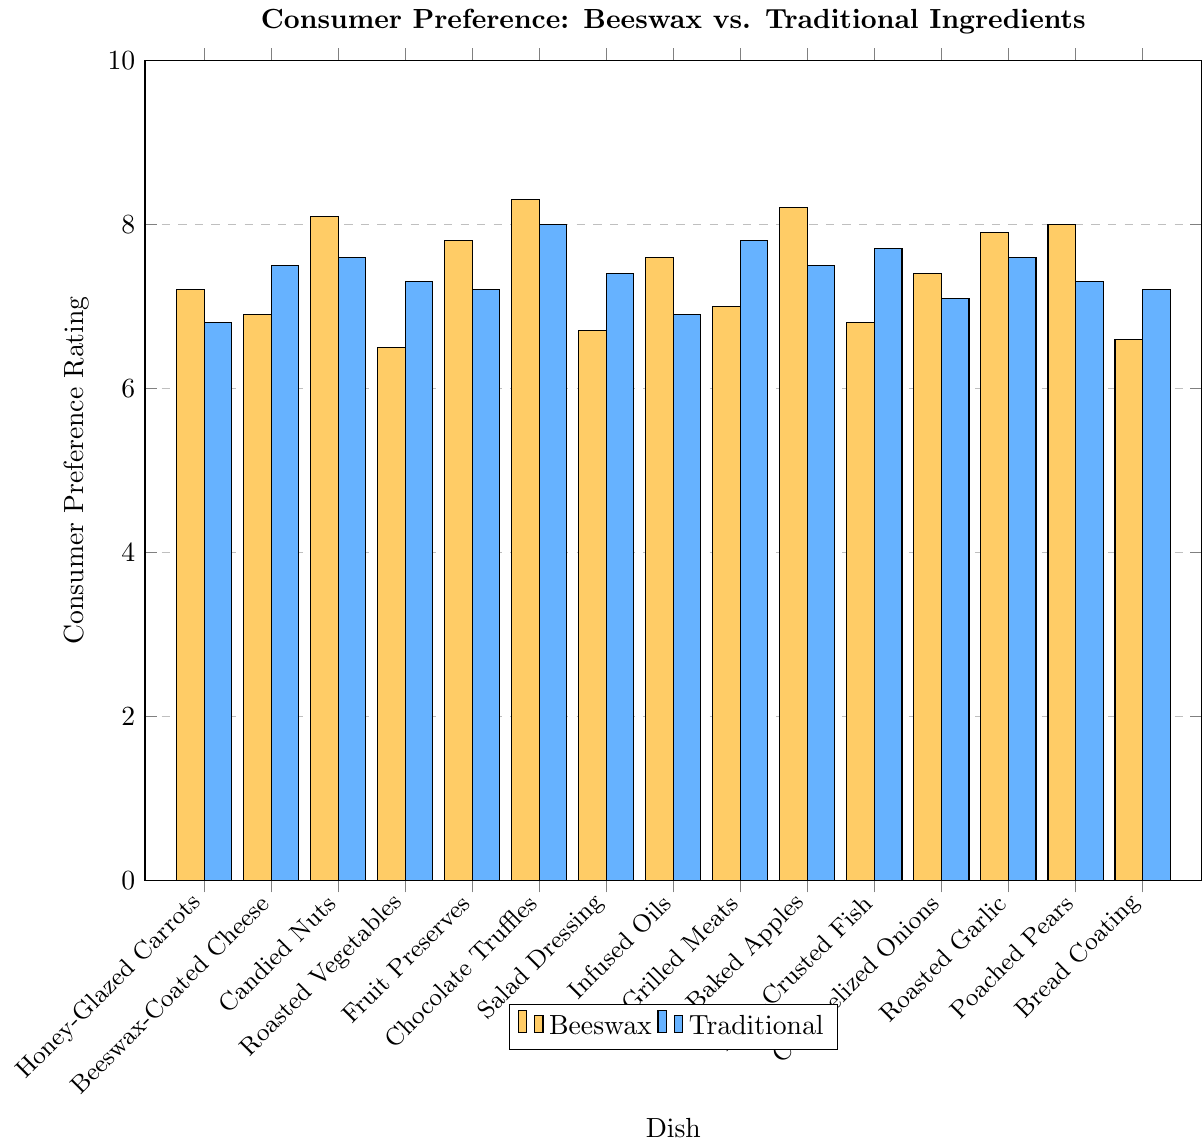What dish has the highest beeswax rating? To find the highest beeswax rating, look for the tallest bar in the beeswax series. The tallest bar belongs to "Chocolate Truffles" with a rating of 8.3.
Answer: Chocolate Truffles Which dish has the largest difference in preference rating between beeswax and traditional ingredients? Calculate the absolute difference between beeswax and traditional ratings for each dish. The largest difference is for "Herb-Crusted Fish" where the beeswax rating (6.8) is lower than the traditional rating (7.7) by 0.9.
Answer: Herb-Crusted Fish What is the average traditional rating across all dishes? Sum all traditional ratings and divide by the number of dishes. The sum of traditional ratings is (6.8 + 7.5 + 7.6 + 7.3 + 7.2 + 8.0 + 7.4 + 6.9 + 7.8 + 7.5 + 7.7 + 7.1 + 7.6 + 7.3 + 7.2) = 112.9, and there are 15 dishes, so the average is 112.9/15 = 7.53.
Answer: 7.53 Which dishes have beeswax ratings higher than their traditional counterparts? Compare each dish's beeswax rating to its traditional rating. The dishes are "Honey-Glazed Carrots," "Candied Nuts," "Fruit Preserves," "Chocolate Truffles," "Infused Oils," "Baked Apples," "Roasted Garlic," and "Poached Pears."
Answer: 8 dishes What is the median beeswax rating? Arrange the beeswax ratings in ascending order and find the middle value. The sorted ratings are (6.5, 6.6, 6.7, 6.8, 6.9, 7.0, 7.2, 7.4, 7.6, 7.8, 7.9, 8.0, 8.1, 8.2, 8.3). The median is the 8th value in this sorted list, which is 7.4.
Answer: 7.4 Which dish shows nearly equal preference for beeswax and traditional ingredients? Identify dishes where the beeswax and traditional ratings are nearly the same. For "Caramelized Onions," beeswax rating is 7.4 and traditional rating is 7.1, making the difference 0.3.
Answer: Caramelized Onions How many dishes have beeswax ratings above 7.5? Count the bars in the beeswax series that exceed the 7.5 mark. The dishes are "Candied Nuts," "Chocolate Truffles," "Fruit Preserves," "Baked Apples," "Roasted Garlic," and "Poached Pears."
Answer: 6 dishes What is the total preference rating for beeswax dishes? Sum all beeswax ratings. The sum is (7.2 + 6.9 + 8.1 + 6.5 + 7.8 + 8.3 + 6.7 + 7.6 + 7.0 + 8.2 + 6.8 + 7.4 + 7.9 + 8.0 + 6.6) = 111.
Answer: 111 